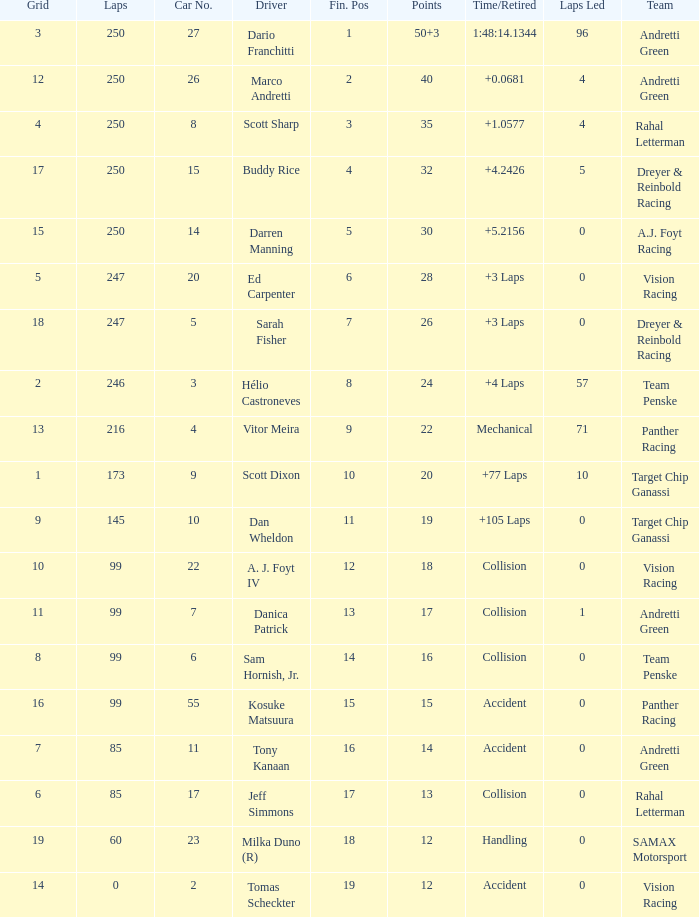What is the grid for the driver who earned 14 points? 7.0. 